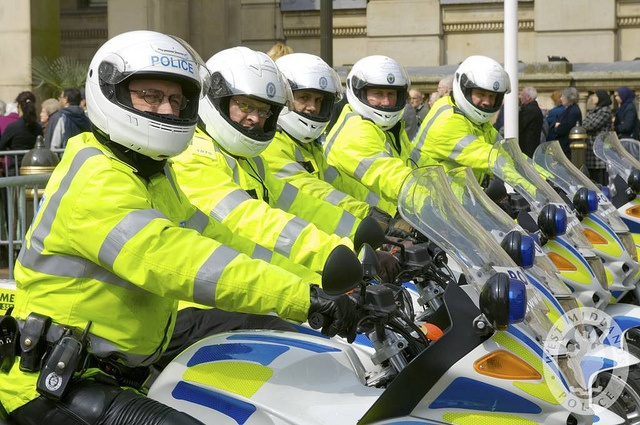Describe the objects in this image and their specific colors. I can see people in tan, black, yellow, and lightgray tones, motorcycle in lightgray, darkgray, black, and gray tones, people in tan, white, yellow, and khaki tones, people in lightgray, yellow, white, darkgray, and khaki tones, and people in lightgray, white, black, darkgray, and yellow tones in this image. 